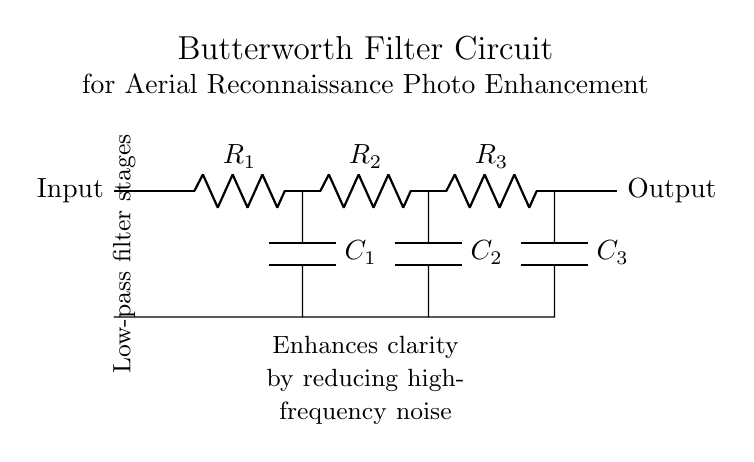What is the type of filter represented by this circuit? The circuit is a Butterworth filter, which is indicated by its name in the title. Butterworth filters are specifically designed for a smooth frequency response with no ripples in the passband.
Answer: Butterworth filter How many resistors are in the circuit? The circuit diagram shows three resistors labeled R1, R2, and R3. Each resistor is essential for defining the cutoff frequency of the filter and determining the gain.
Answer: Three What components are used in this filter circuit? The circuit includes resistors (R1, R2, R3) and capacitors (C1, C2, C3). The combination of these components is crucial for creating the filter’s frequency characteristics.
Answer: Resistors and capacitors What is the purpose of the circuit according to the annotations? The annotation states that the circuit "enhances clarity by reducing high-frequency noise," which describes its primary function in processing aerial reconnaissance photographs.
Answer: Enhances clarity How many stages are in the Butterworth filter? The circuit consists of three stages, each made up of a resistor and a capacitor in series, which form low-pass filter stages to improve the quality of the output signal.
Answer: Three stages What is the output of this circuit labeled as? The output is labeled as "Output" in the circuit diagram, indicating the processed signal ready for further use or analysis.
Answer: Output 